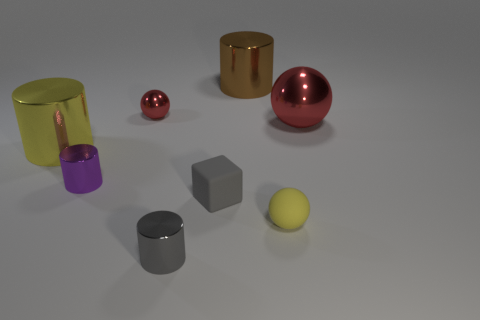Subtract all yellow shiny cylinders. How many cylinders are left? 3 Add 1 tiny red metal balls. How many objects exist? 9 Subtract all yellow cylinders. How many cylinders are left? 3 Subtract all balls. How many objects are left? 5 Subtract 2 balls. How many balls are left? 1 Subtract all brown spheres. Subtract all brown cubes. How many spheres are left? 3 Subtract all shiny cylinders. Subtract all yellow shiny cylinders. How many objects are left? 3 Add 5 tiny gray cubes. How many tiny gray cubes are left? 6 Add 7 tiny metal objects. How many tiny metal objects exist? 10 Subtract 2 red spheres. How many objects are left? 6 